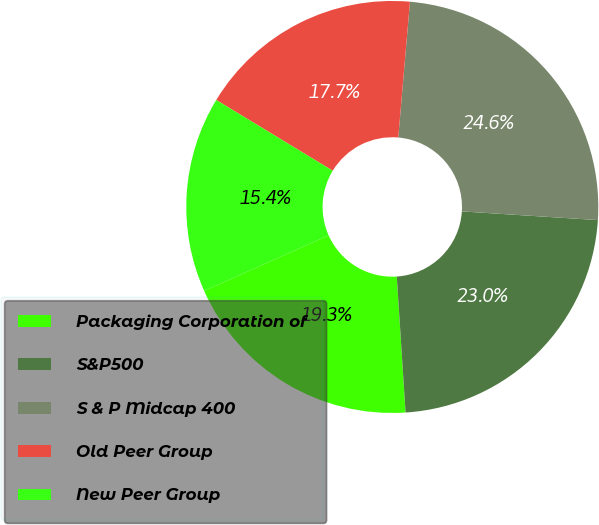Convert chart to OTSL. <chart><loc_0><loc_0><loc_500><loc_500><pie_chart><fcel>Packaging Corporation of<fcel>S&P500<fcel>S & P Midcap 400<fcel>Old Peer Group<fcel>New Peer Group<nl><fcel>19.35%<fcel>22.96%<fcel>24.65%<fcel>17.68%<fcel>15.37%<nl></chart> 